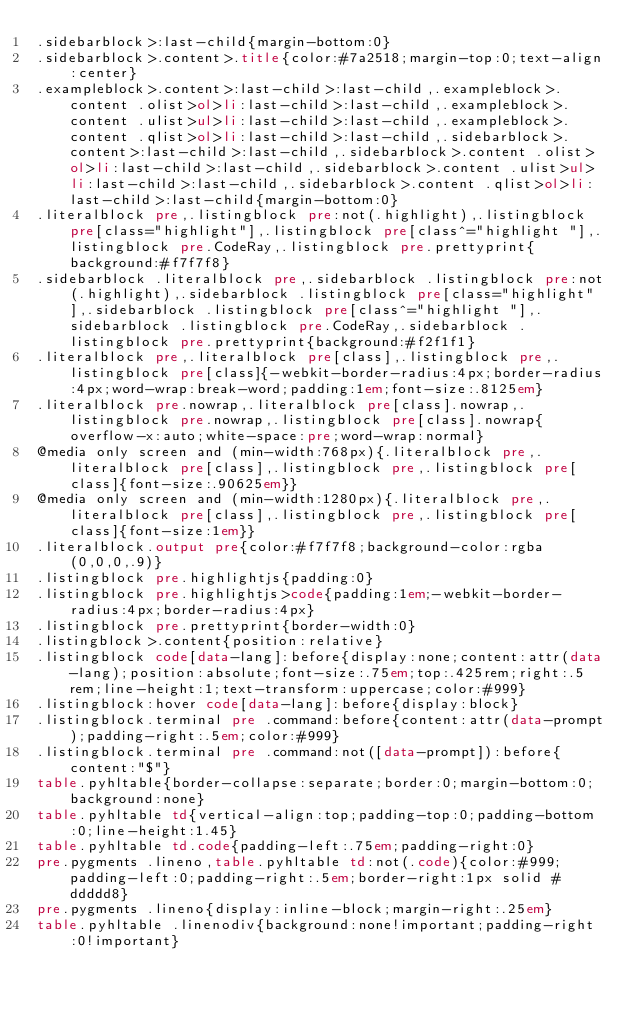Convert code to text. <code><loc_0><loc_0><loc_500><loc_500><_HTML_>.sidebarblock>:last-child{margin-bottom:0}
.sidebarblock>.content>.title{color:#7a2518;margin-top:0;text-align:center}
.exampleblock>.content>:last-child>:last-child,.exampleblock>.content .olist>ol>li:last-child>:last-child,.exampleblock>.content .ulist>ul>li:last-child>:last-child,.exampleblock>.content .qlist>ol>li:last-child>:last-child,.sidebarblock>.content>:last-child>:last-child,.sidebarblock>.content .olist>ol>li:last-child>:last-child,.sidebarblock>.content .ulist>ul>li:last-child>:last-child,.sidebarblock>.content .qlist>ol>li:last-child>:last-child{margin-bottom:0}
.literalblock pre,.listingblock pre:not(.highlight),.listingblock pre[class="highlight"],.listingblock pre[class^="highlight "],.listingblock pre.CodeRay,.listingblock pre.prettyprint{background:#f7f7f8}
.sidebarblock .literalblock pre,.sidebarblock .listingblock pre:not(.highlight),.sidebarblock .listingblock pre[class="highlight"],.sidebarblock .listingblock pre[class^="highlight "],.sidebarblock .listingblock pre.CodeRay,.sidebarblock .listingblock pre.prettyprint{background:#f2f1f1}
.literalblock pre,.literalblock pre[class],.listingblock pre,.listingblock pre[class]{-webkit-border-radius:4px;border-radius:4px;word-wrap:break-word;padding:1em;font-size:.8125em}
.literalblock pre.nowrap,.literalblock pre[class].nowrap,.listingblock pre.nowrap,.listingblock pre[class].nowrap{overflow-x:auto;white-space:pre;word-wrap:normal}
@media only screen and (min-width:768px){.literalblock pre,.literalblock pre[class],.listingblock pre,.listingblock pre[class]{font-size:.90625em}}
@media only screen and (min-width:1280px){.literalblock pre,.literalblock pre[class],.listingblock pre,.listingblock pre[class]{font-size:1em}}
.literalblock.output pre{color:#f7f7f8;background-color:rgba(0,0,0,.9)}
.listingblock pre.highlightjs{padding:0}
.listingblock pre.highlightjs>code{padding:1em;-webkit-border-radius:4px;border-radius:4px}
.listingblock pre.prettyprint{border-width:0}
.listingblock>.content{position:relative}
.listingblock code[data-lang]:before{display:none;content:attr(data-lang);position:absolute;font-size:.75em;top:.425rem;right:.5rem;line-height:1;text-transform:uppercase;color:#999}
.listingblock:hover code[data-lang]:before{display:block}
.listingblock.terminal pre .command:before{content:attr(data-prompt);padding-right:.5em;color:#999}
.listingblock.terminal pre .command:not([data-prompt]):before{content:"$"}
table.pyhltable{border-collapse:separate;border:0;margin-bottom:0;background:none}
table.pyhltable td{vertical-align:top;padding-top:0;padding-bottom:0;line-height:1.45}
table.pyhltable td.code{padding-left:.75em;padding-right:0}
pre.pygments .lineno,table.pyhltable td:not(.code){color:#999;padding-left:0;padding-right:.5em;border-right:1px solid #ddddd8}
pre.pygments .lineno{display:inline-block;margin-right:.25em}
table.pyhltable .linenodiv{background:none!important;padding-right:0!important}</code> 